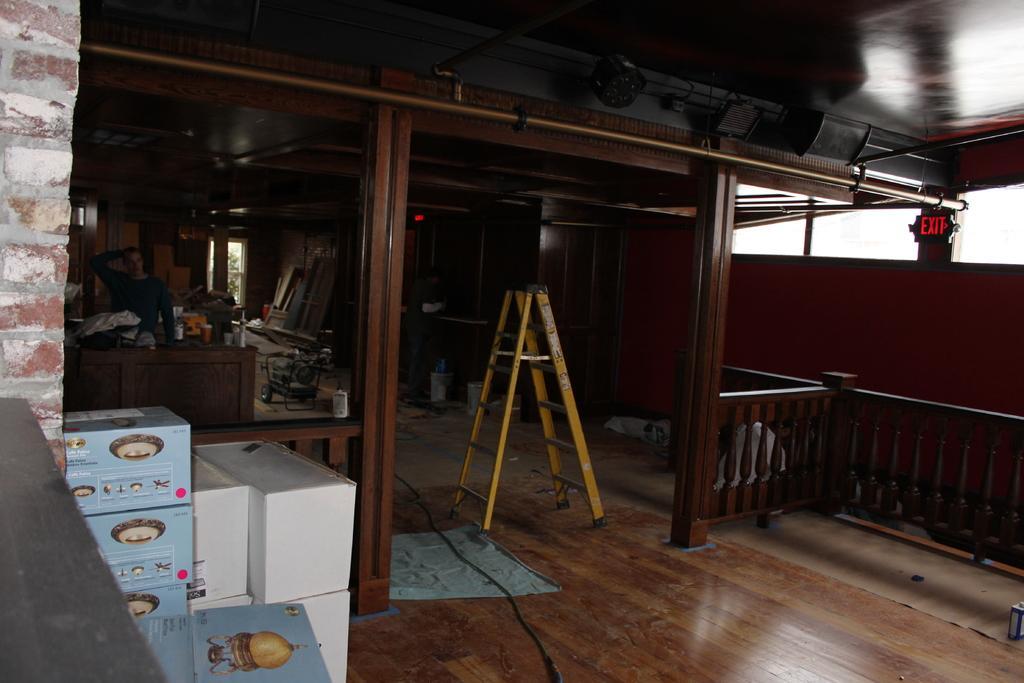Describe this image in one or two sentences. In this image on the left side there are some boxes, and in the center there is a ladder and on the right side there is a railing. In the background there are some tables, window, door and some other objects. At the bottom there is floor, on the floor there is wire and at the top there is ceiling and some lights. On the left side there is a wall and table. 